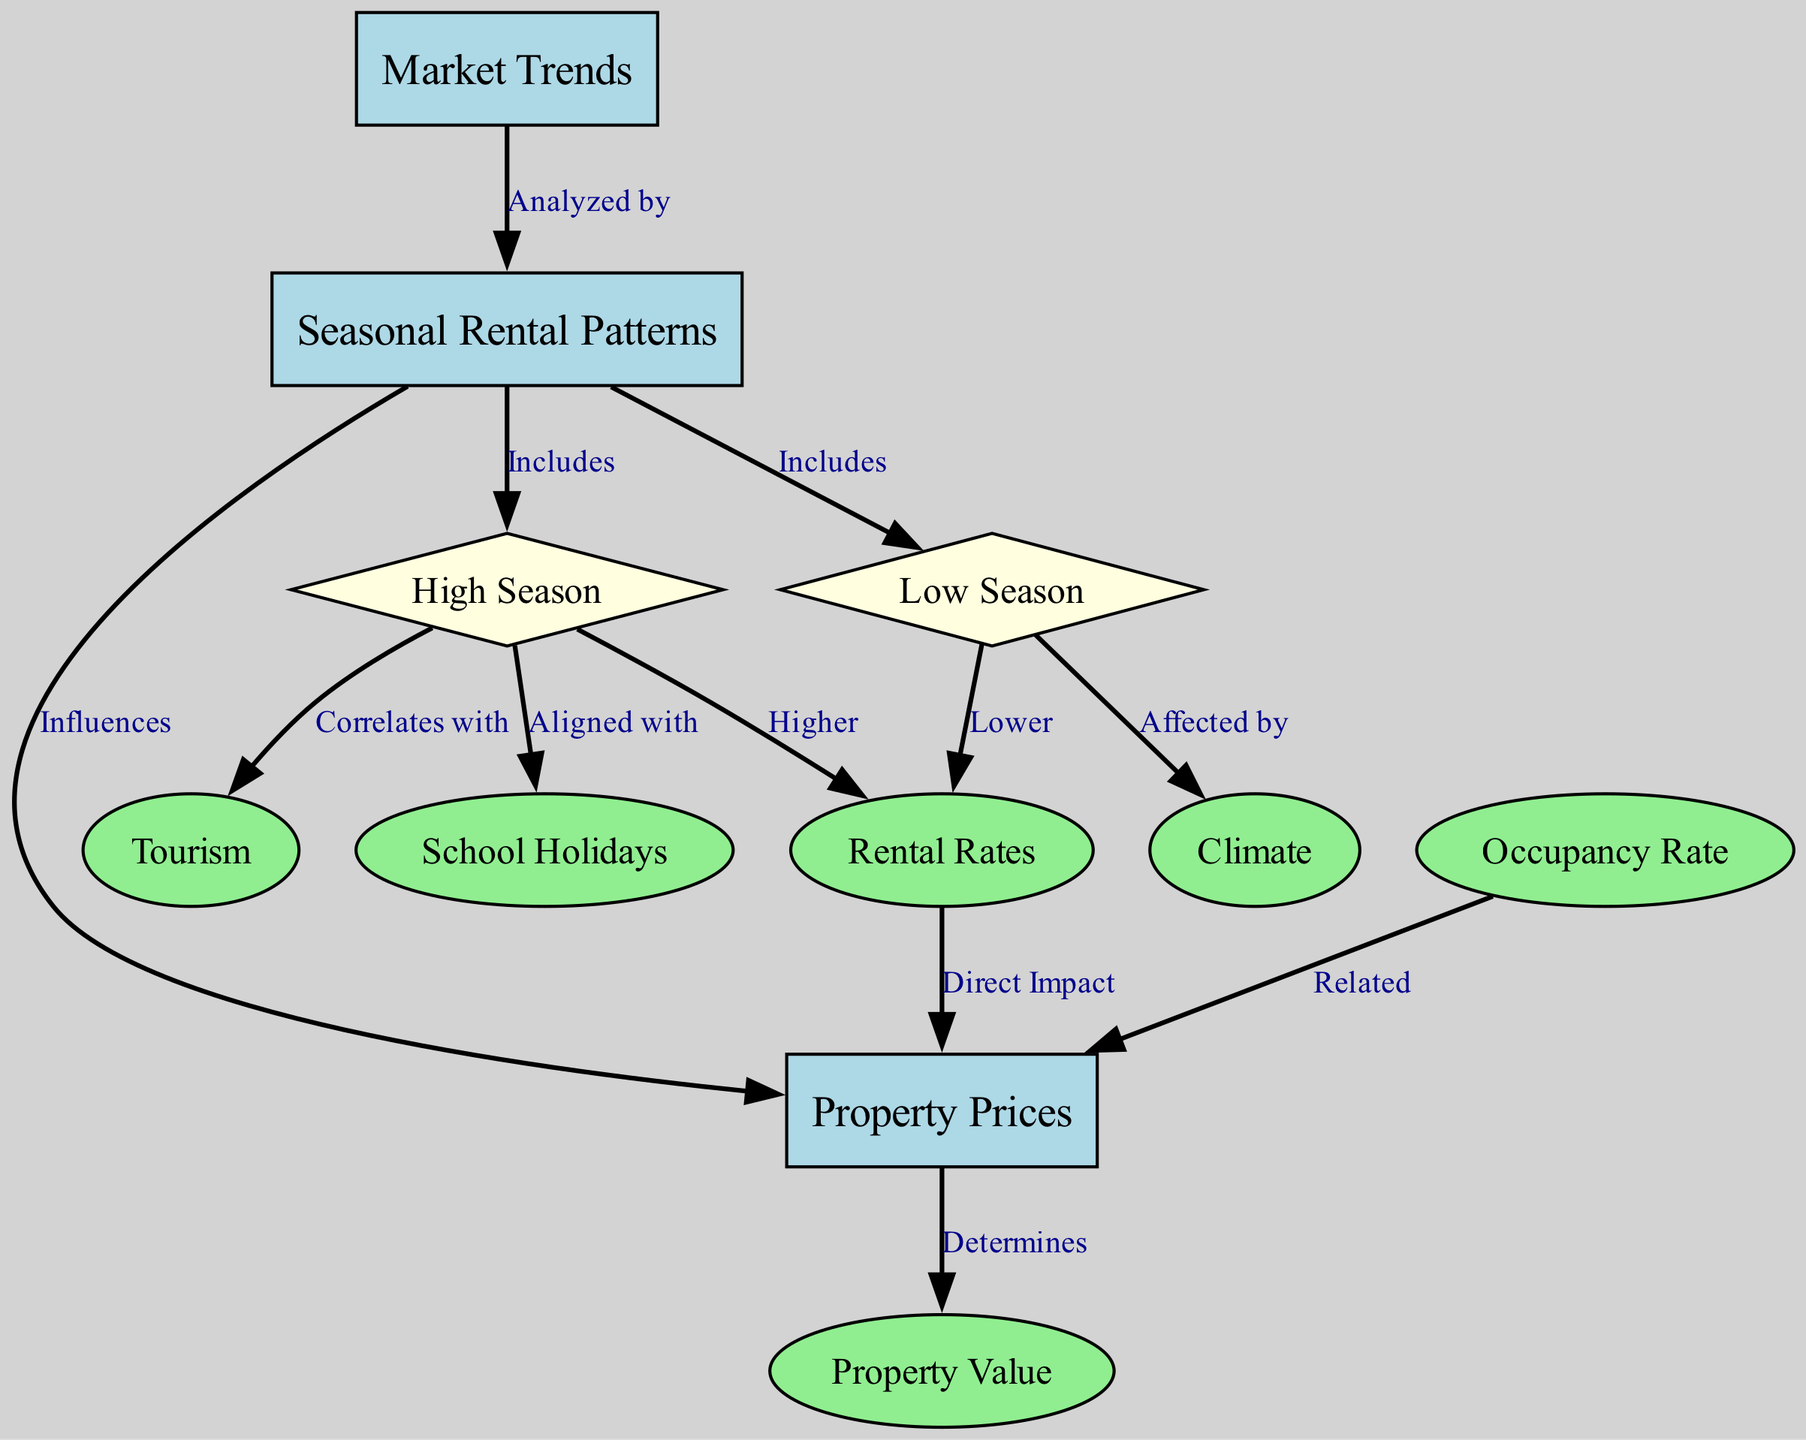What are the three main nodes in this diagram? The main nodes can be identified by their classification: boxes represent key concepts, which in this diagram are "Market Trends," "Seasonal Rental Patterns," and "Property Prices."
Answer: Market Trends, Seasonal Rental Patterns, Property Prices How many nodes are present in the diagram? The total number of nodes can be counted directly from the nodes list, which includes 10 distinct nodes.
Answer: 10 What does "Seasonal Rental Patterns" influence directly? Following the edges from "Seasonal Rental Patterns," it shows that it directly influences "Property Prices."
Answer: Property Prices Which season correlates with high tourism? The edge indicates that "High Season" correlates with "Tourism." Thus, one can conclude that high tourism occurs during the high season.
Answer: High Season What is the relationship between "Occupancy Rate" and "Property Prices"? The diagram shows that there is a relationship labeled "Related," indicating that changes in occupancy rates can affect property prices.
Answer: Related During which season are rental rates higher? By examining the connections from "Seasonal Rental Patterns," it's clear that "High Season" is associated with higher rental rates.
Answer: High Season What affects the low season? The diagram shows an edge indicating that "Low Season" is affected by "Climate," suggesting that climate conditions play a role in determining low season trends.
Answer: Climate What determines property value? Following the flow from "Property Prices," the diagram indicates that property prices determine "Property Value."
Answer: Property Prices Which two time frames are included in seasonal rental patterns? The diagram illustrates that "Seasonal Rental Patterns" includes both "High Season" and "Low Season," representing different rental trends throughout the year.
Answer: High Season, Low Season 